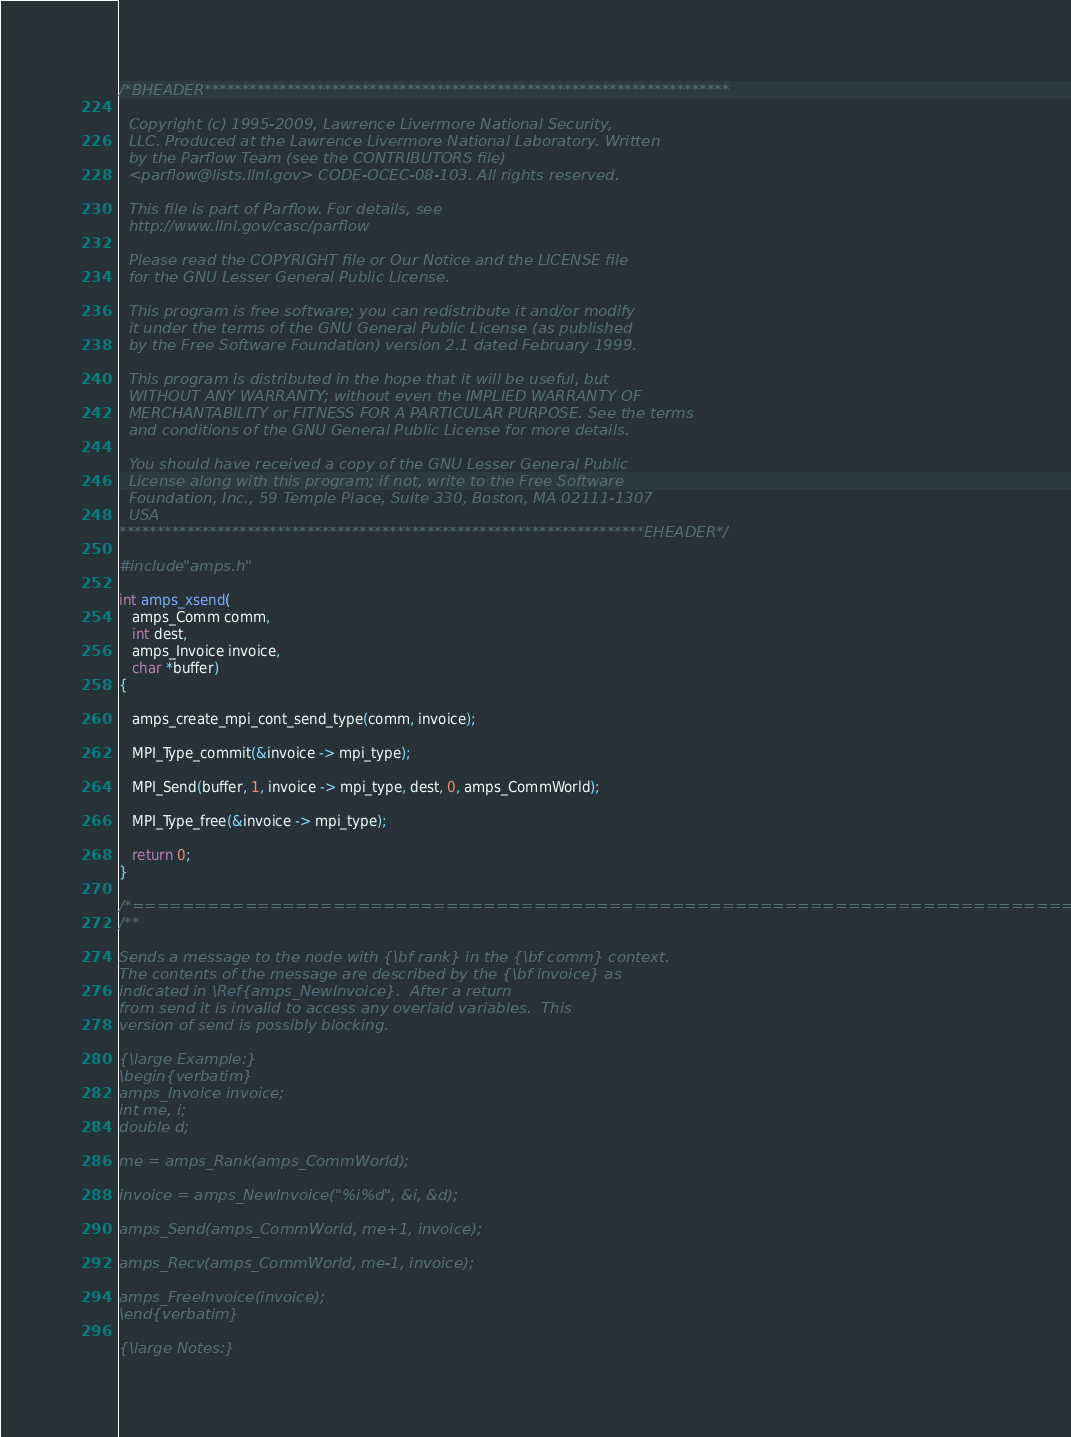Convert code to text. <code><loc_0><loc_0><loc_500><loc_500><_C_>/*BHEADER**********************************************************************

  Copyright (c) 1995-2009, Lawrence Livermore National Security,
  LLC. Produced at the Lawrence Livermore National Laboratory. Written
  by the Parflow Team (see the CONTRIBUTORS file)
  <parflow@lists.llnl.gov> CODE-OCEC-08-103. All rights reserved.

  This file is part of Parflow. For details, see
  http://www.llnl.gov/casc/parflow

  Please read the COPYRIGHT file or Our Notice and the LICENSE file
  for the GNU Lesser General Public License.

  This program is free software; you can redistribute it and/or modify
  it under the terms of the GNU General Public License (as published
  by the Free Software Foundation) version 2.1 dated February 1999.

  This program is distributed in the hope that it will be useful, but
  WITHOUT ANY WARRANTY; without even the IMPLIED WARRANTY OF
  MERCHANTABILITY or FITNESS FOR A PARTICULAR PURPOSE. See the terms
  and conditions of the GNU General Public License for more details.

  You should have received a copy of the GNU Lesser General Public
  License along with this program; if not, write to the Free Software
  Foundation, Inc., 59 Temple Place, Suite 330, Boston, MA 02111-1307
  USA
**********************************************************************EHEADER*/

#include "amps.h"

int amps_xsend(
   amps_Comm comm,
   int dest,
   amps_Invoice invoice,
   char *buffer)
{

   amps_create_mpi_cont_send_type(comm, invoice);

   MPI_Type_commit(&invoice -> mpi_type);

   MPI_Send(buffer, 1, invoice -> mpi_type, dest, 0, amps_CommWorld);

   MPI_Type_free(&invoice -> mpi_type);      

   return 0;
}

/*===========================================================================*/
/**

Sends a message to the node with {\bf rank} in the {\bf comm} context.
The contents of the message are described by the {\bf invoice} as
indicated in \Ref{amps_NewInvoice}.  After a return
from send it is invalid to access any overlaid variables.  This
version of send is possibly blocking.  

{\large Example:}
\begin{verbatim}
amps_Invoice invoice;
int me, i;
double d;

me = amps_Rank(amps_CommWorld);

invoice = amps_NewInvoice("%i%d", &i, &d);

amps_Send(amps_CommWorld, me+1, invoice);

amps_Recv(amps_CommWorld, me-1, invoice);

amps_FreeInvoice(invoice);
\end{verbatim}

{\large Notes:}
</code> 